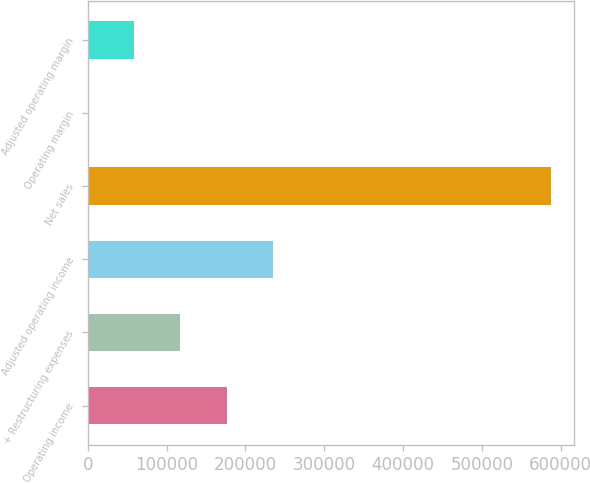Convert chart to OTSL. <chart><loc_0><loc_0><loc_500><loc_500><bar_chart><fcel>Operating income<fcel>+ Restructuring expenses<fcel>Adjusted operating income<fcel>Net sales<fcel>Operating margin<fcel>Adjusted operating margin<nl><fcel>176277<fcel>117527<fcel>235028<fcel>587533<fcel>25<fcel>58775.8<nl></chart> 